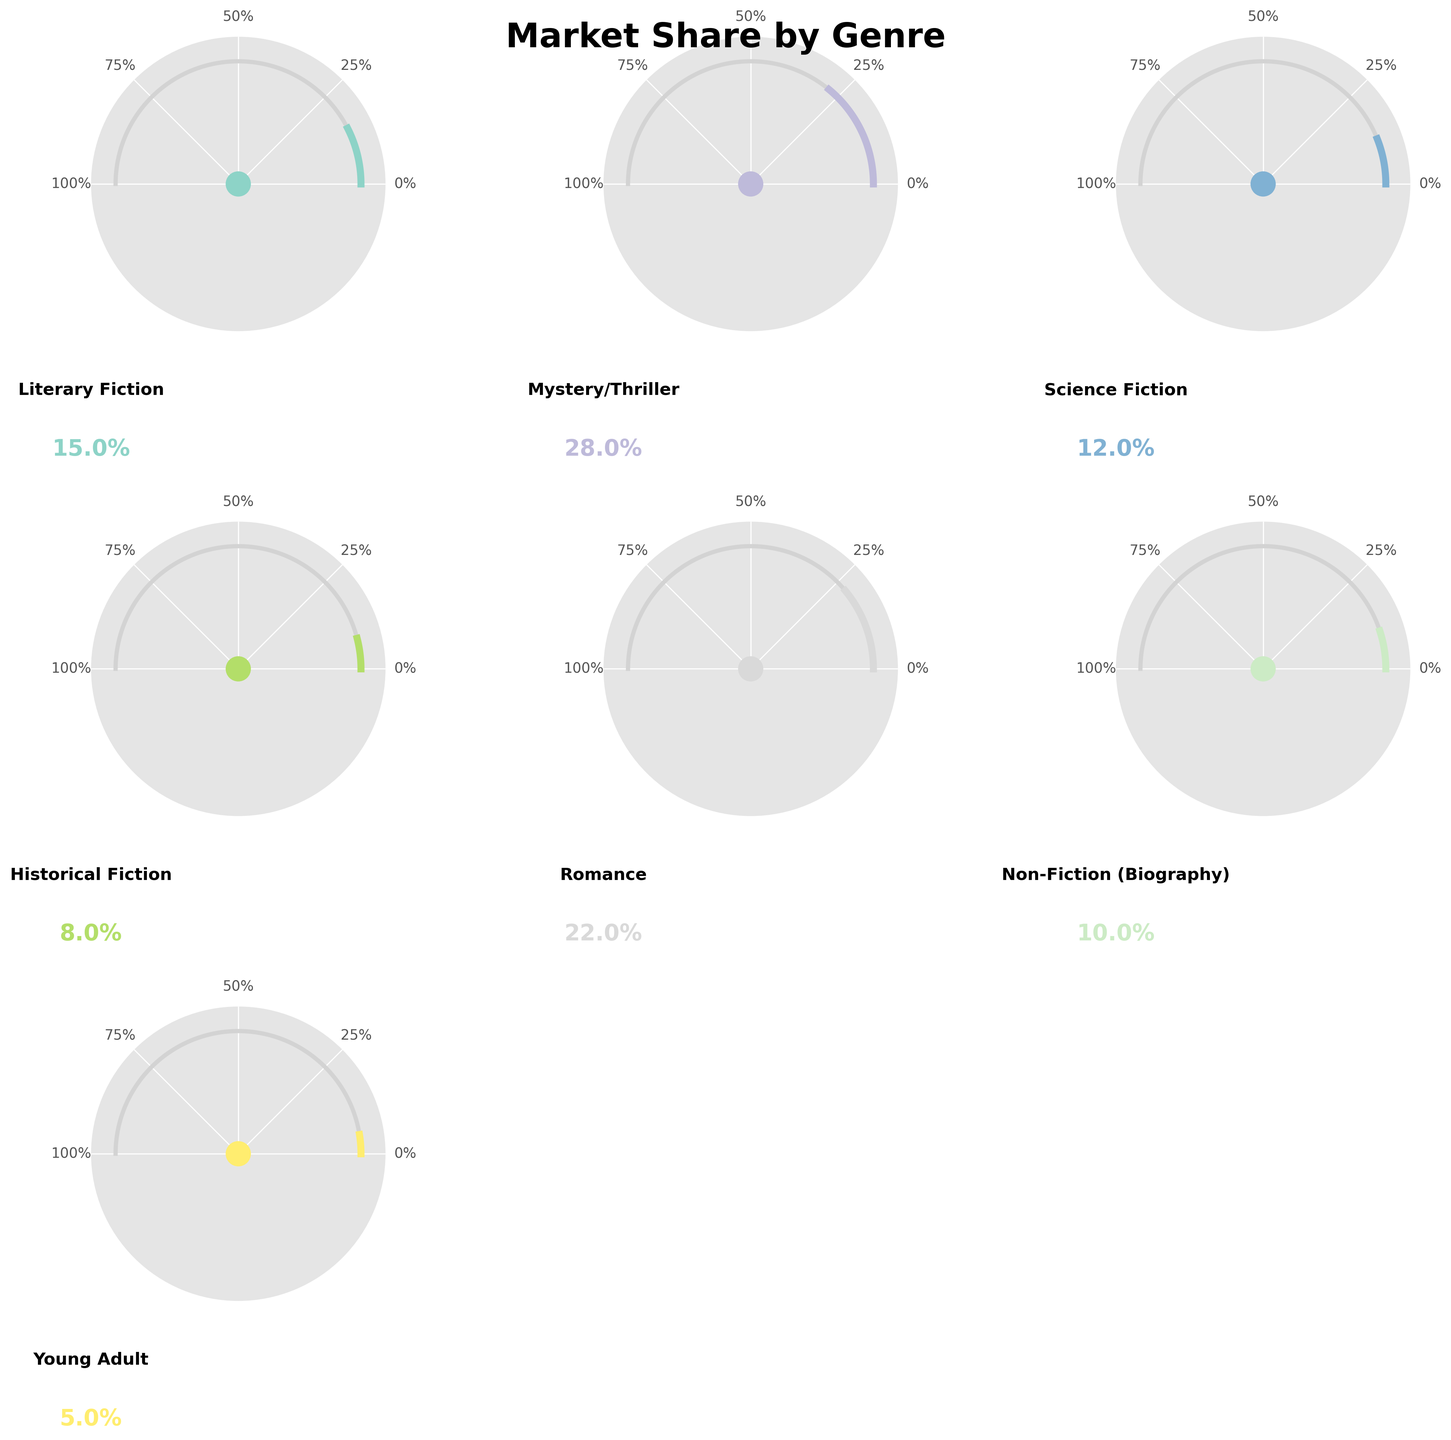What is the market share of the "Romance" genre? The market share of the "Romance" genre can be directly read from the figure. In the Romance section, the gauge represents 22% market share.
Answer: 22% Which genre has the smallest market share, and what is that share? The genre with the smallest market share will be the one where the gauge is least filled. The "Young Adult" genre has the smallest market share at 5%.
Answer: Young Adult, 5% Compare the market shares of "Mystery/Thriller" and "Literary Fiction". Which one is greater, and by how much? The "Mystery/Thriller" genre has a market share of 28%, while "Literary Fiction" has a market share of 15%. To find the difference, subtract 15% from 28%.
Answer: Mystery/Thriller, by 13% What is the combined market share of "Science Fiction" and "Historical Fiction"? Add the market share of "Science Fiction" (12%) and "Historical Fiction" (8%) to get the combined market share.
Answer: 20% How many genres have a market share of 10% or higher? Count the genres with market shares equal to or greater than 10%. "Literary Fiction," "Mystery/Thriller," "Science Fiction," "Romance," and "Non-Fiction (Biography)" meet this criterion, so there are 5 genres in total.
Answer: 5 Which genre nearly reaches the halfway mark (50%) in market share? Look for the gauge that is most filled towards the halfway mark. None of the genres reach 50%, but "Mystery/Thriller" comes the closest with 28%.
Answer: Mystery/Thriller If the total market share of all genres is represented as 100%, what percentage more is the market share of "Mystery/Thriller" compared to "Science Fiction"? First calculate the difference in market share (28% - 12% = 16%). Then, calculate the percentage increase relative to "Science Fiction" (16/12 * 100%).
Answer: 133.33% By visual appearance, which genre has the most saturated color representation on its gauge? Saturated color representation can be observed by looking at which gauge section has the most strongly colored segment. All genres use a color from the Set3 color palette, but "Mystery/Thriller" stands out with a more prominent color due to its larger share.
Answer: Mystery/Thriller What is the average market share across all the genres? Sum all the market shares (0.15 + 0.28 + 0.12 + 0.08 + 0.22 + 0.10 + 0.05) = 1.00 or 100%. Then, divide by the number of genres (7).
Answer: 14.29% 